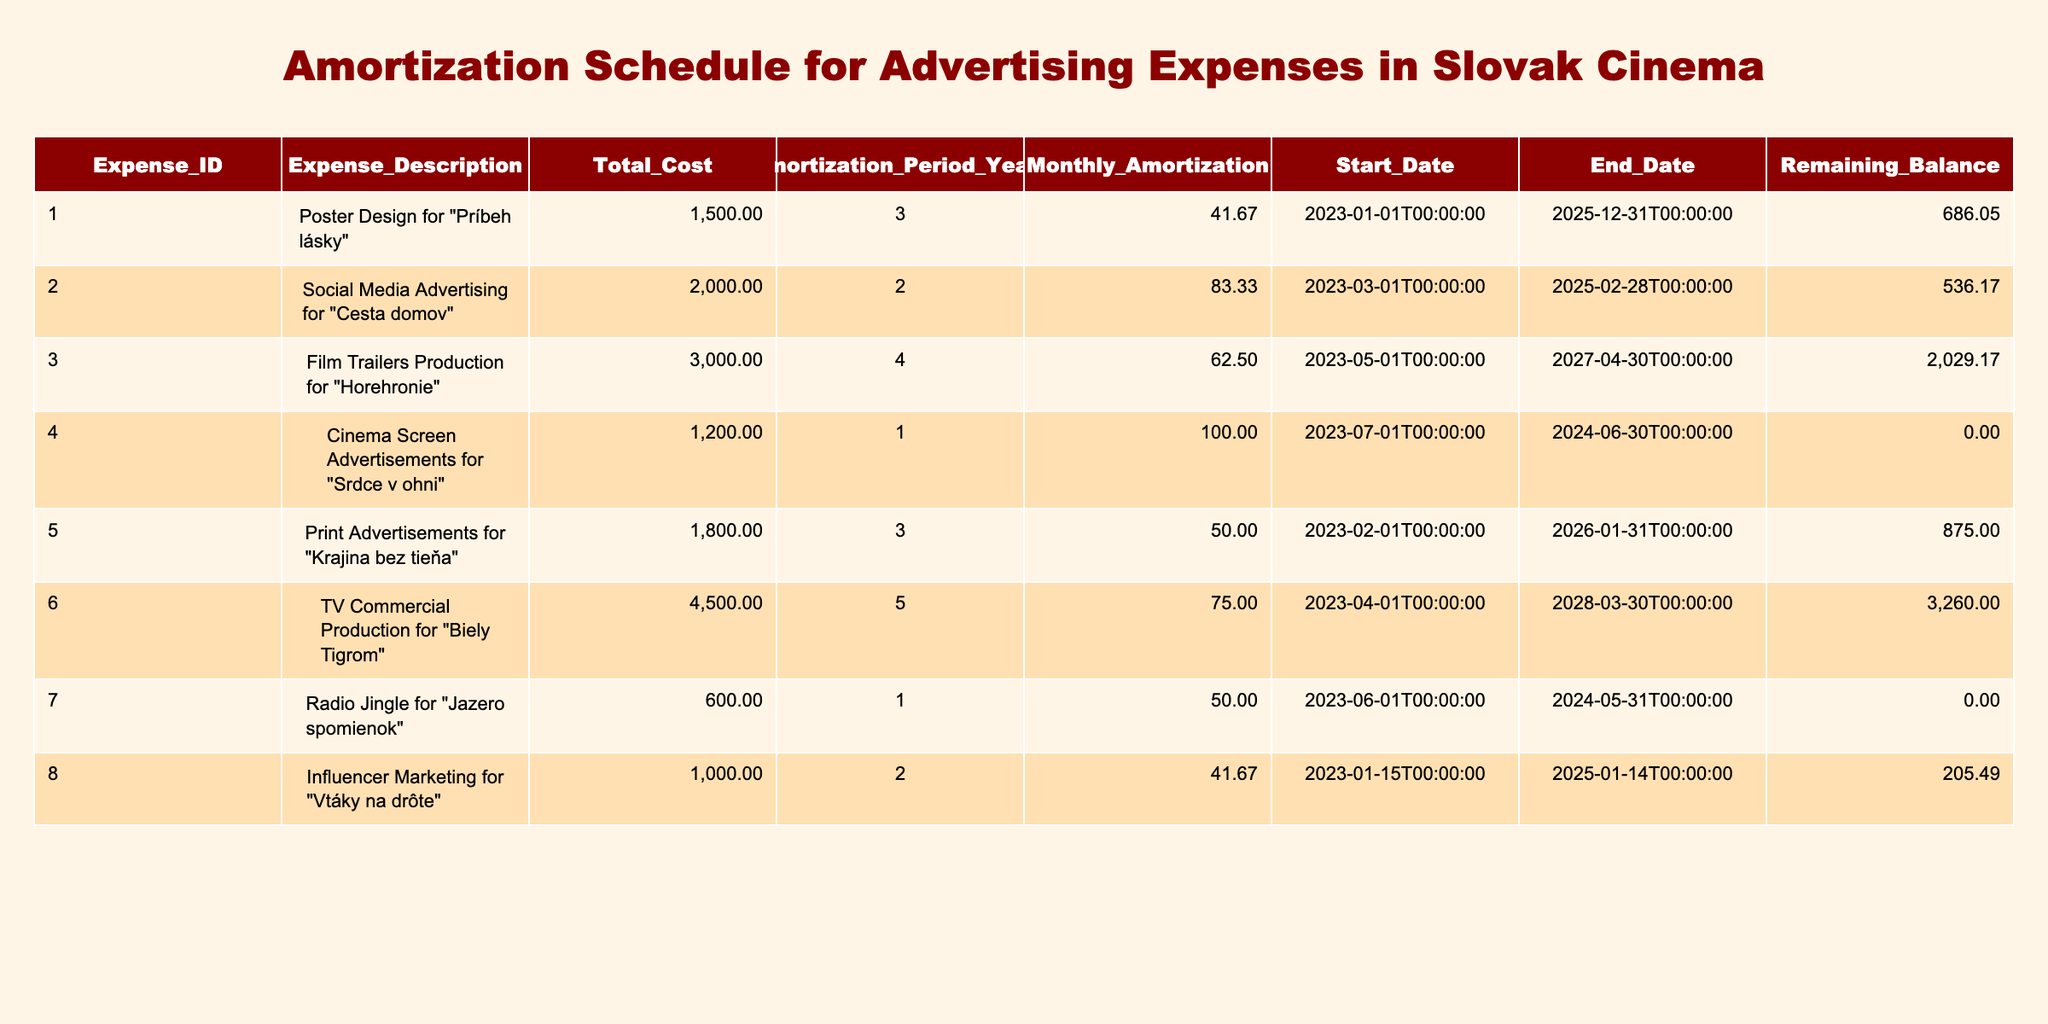What is the total cost of the advertising expense for “Cesta domov”? The table shows that the advertising expense for "Cesta domov" has a total cost of 2000.
Answer: 2000 What is the monthly amortization amount for “Horehronie”? Looking at the table, the monthly amortization for "Horehronie" is 62.50.
Answer: 62.50 Which advertising expense has the shortest amortization period? The table indicates that "Srdce v ohni" has an amortization period of 1 year, which is the shortest compared to the other expenses listed.
Answer: Srdce v ohni What is the remaining balance for “Príbeh lásky” as of today? The remaining balance for "Príbeh lásky" can be calculated by taking the total cost of 1500 and subtracting the accumulated amortization. As today is October 2023, almost 10 months of amortization have occurred, which is approximately 416.67. Thus, the remaining balance is 1500 - 416.67 = 1083.33.
Answer: 1083.33 Is the total cost of advertising expenses for “Krajina bez tieňa” more than 1500? The total cost for "Krajina bez tieňa" is 1800, which is greater than 1500; thus the answer is true.
Answer: Yes What is the average monthly amortization of all the expenses listed in the table? To find the average monthly amortization, we sum all monthly amortizations: (41.67 + 83.33 + 62.50 + 100.00 + 50.00 + 75.00 + 50.00 + 41.67) = 505.17. There are 8 expenses, so the average is 505.17 / 8 = 63.15.
Answer: 63.15 For which advertising expense was the start date the earliest? Reviewing the start dates in the table, "Príbeh lásky" started on 2023-01-01, which is the earliest compared to all other listed expenses.
Answer: Príbeh lásky What is the remaining balance for the “Biely Tigrom” advertising expense? "Biely Tigrom" has a total cost of 4500 with a monthly amortization of 75. To calculate the remaining balance, we assess the time since it started in April 2023 until now. Assuming it has been 6 months, the amortization is 75 * 6 = 450. Hence, the remaining balance is 4500 - 450 = 4050.
Answer: 4050 Is there an expense that has a total cost less than 1000? By examining the total costs listed, the expense for "Jazero spomienok" is 600, which is indeed less than 1000; thus the answer is true.
Answer: Yes 